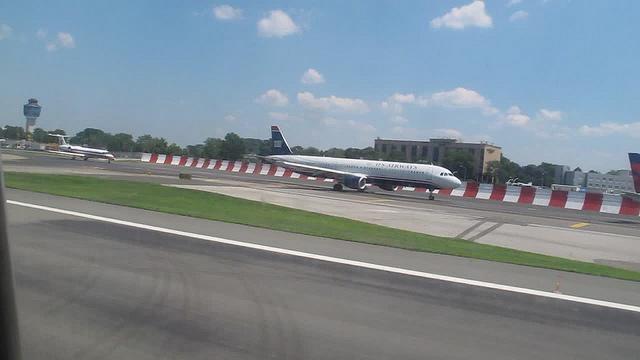How many airplanes are on the runway?
Answer briefly. 2. Is there more than 1 plane?
Quick response, please. Yes. Are there clouds?
Be succinct. Yes. 